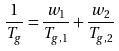Convert formula to latex. <formula><loc_0><loc_0><loc_500><loc_500>\frac { 1 } { T _ { g } } = \frac { w _ { 1 } } { T _ { g , 1 } } + \frac { w _ { 2 } } { T _ { g , 2 } }</formula> 